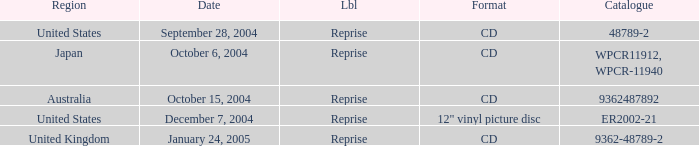Name the october 15, 2004 catalogue 9362487892.0. 